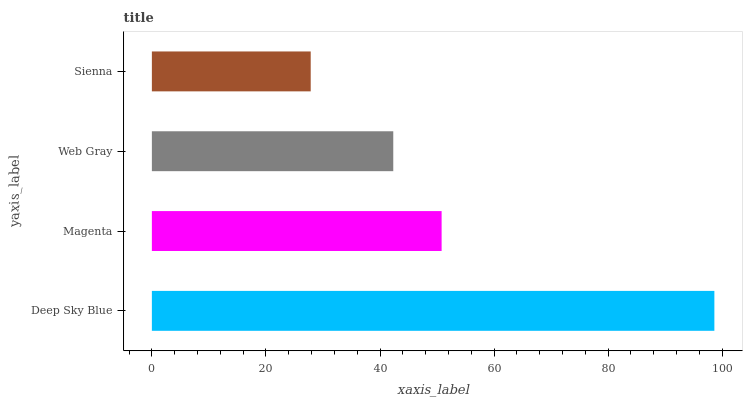Is Sienna the minimum?
Answer yes or no. Yes. Is Deep Sky Blue the maximum?
Answer yes or no. Yes. Is Magenta the minimum?
Answer yes or no. No. Is Magenta the maximum?
Answer yes or no. No. Is Deep Sky Blue greater than Magenta?
Answer yes or no. Yes. Is Magenta less than Deep Sky Blue?
Answer yes or no. Yes. Is Magenta greater than Deep Sky Blue?
Answer yes or no. No. Is Deep Sky Blue less than Magenta?
Answer yes or no. No. Is Magenta the high median?
Answer yes or no. Yes. Is Web Gray the low median?
Answer yes or no. Yes. Is Deep Sky Blue the high median?
Answer yes or no. No. Is Sienna the low median?
Answer yes or no. No. 